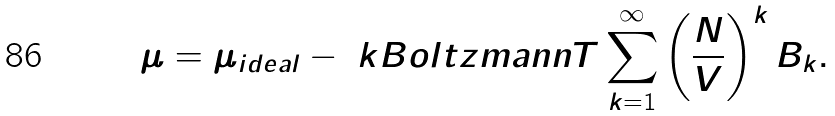<formula> <loc_0><loc_0><loc_500><loc_500>\mu = \mu _ { i d e a l } - \ k B o l t z m a n n T \sum _ { k = 1 } ^ { \infty } \left ( \frac { N } { V } \right ) ^ { k } B _ { k } .</formula> 